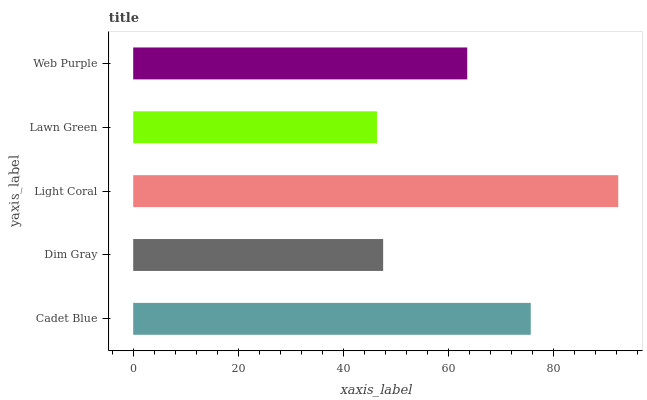Is Lawn Green the minimum?
Answer yes or no. Yes. Is Light Coral the maximum?
Answer yes or no. Yes. Is Dim Gray the minimum?
Answer yes or no. No. Is Dim Gray the maximum?
Answer yes or no. No. Is Cadet Blue greater than Dim Gray?
Answer yes or no. Yes. Is Dim Gray less than Cadet Blue?
Answer yes or no. Yes. Is Dim Gray greater than Cadet Blue?
Answer yes or no. No. Is Cadet Blue less than Dim Gray?
Answer yes or no. No. Is Web Purple the high median?
Answer yes or no. Yes. Is Web Purple the low median?
Answer yes or no. Yes. Is Lawn Green the high median?
Answer yes or no. No. Is Lawn Green the low median?
Answer yes or no. No. 